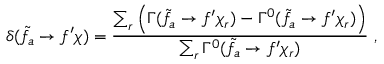<formula> <loc_0><loc_0><loc_500><loc_500>\delta ( \tilde { f _ { a } } \to f ^ { \prime } \chi ) = \frac { \sum _ { r } \left ( \Gamma ( \tilde { f _ { a } } \to f ^ { \prime } \chi _ { r } ) - \Gamma ^ { 0 } ( \tilde { f _ { a } } \to f ^ { \prime } \chi _ { r } ) \right ) } { \sum _ { r } \Gamma ^ { 0 } ( \tilde { f _ { a } } \to f ^ { \prime } \chi _ { r } ) } \, ,</formula> 